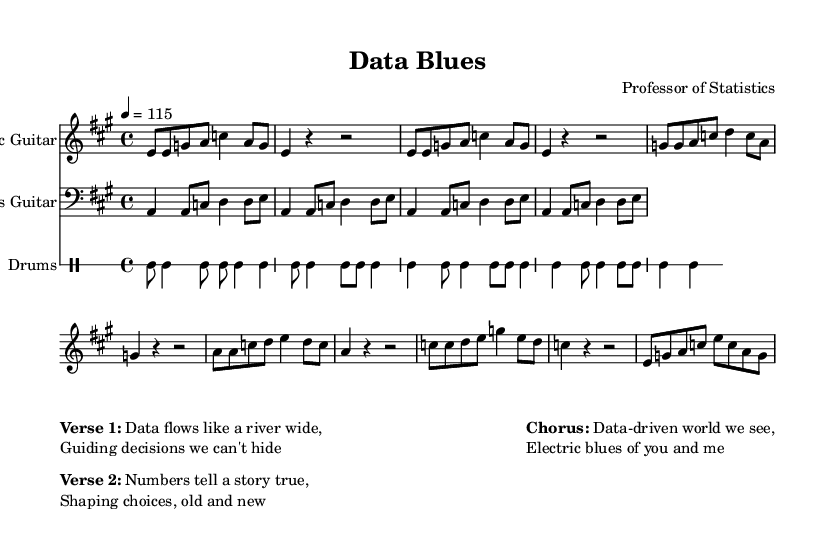What is the time signature of this music? The time signature is indicated at the beginning of the score, appearing as a fraction, which in this case is 4/4. This means there are four beats in each measure.
Answer: 4/4 What is the key signature of this music? The key signature appears next to the clef at the beginning of the score. It shows one sharp, indicating that the key of A major is used, which has three sharps (F#, C#, and G#).
Answer: A major What is the tempo marking for this piece? The tempo marking is shown just below the time signature, indicating the speed of the piece. Here, it is marked as "4 = 115," which means there are 115 beats per minute.
Answer: 115 How many measures are in the verse section? To find this, count the measures in the 'Verse' section indicated in the notation. There are four measures listed under this section.
Answer: 4 What instruments are featured in this piece? The score indicates three instruments: Electric Guitar, Bass Guitar, and Drums. Each instrument's name appears at the beginning of its respective staff.
Answer: Electric Guitar, Bass Guitar, Drums What lyrical theme is presented in the chorus? The chorus discusses the impact of data on decision-making, emphasizing a "data-driven world," which reflects the theme of electric blues connecting to modern analysis.
Answer: Data-driven world How does the bass guitar line relate to the melody? The bass guitar complements the electric guitar by providing a rhythmic foundation, emphasizing the root notes and outlining the harmonic progression that supports the electric guitar melody.
Answer: Supports the melody 